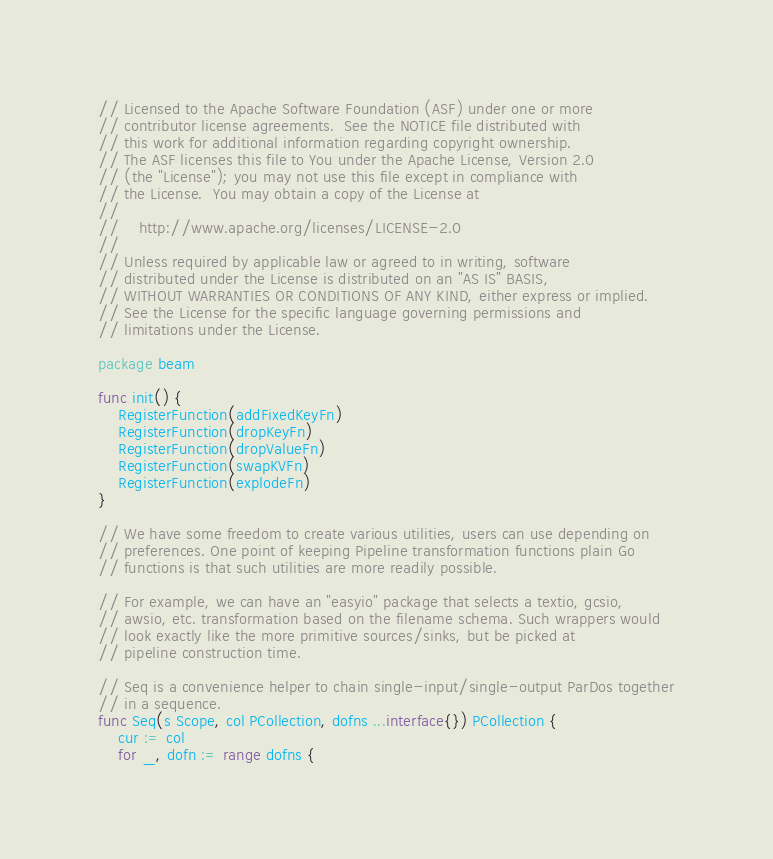Convert code to text. <code><loc_0><loc_0><loc_500><loc_500><_Go_>// Licensed to the Apache Software Foundation (ASF) under one or more
// contributor license agreements.  See the NOTICE file distributed with
// this work for additional information regarding copyright ownership.
// The ASF licenses this file to You under the Apache License, Version 2.0
// (the "License"); you may not use this file except in compliance with
// the License.  You may obtain a copy of the License at
//
//    http://www.apache.org/licenses/LICENSE-2.0
//
// Unless required by applicable law or agreed to in writing, software
// distributed under the License is distributed on an "AS IS" BASIS,
// WITHOUT WARRANTIES OR CONDITIONS OF ANY KIND, either express or implied.
// See the License for the specific language governing permissions and
// limitations under the License.

package beam

func init() {
	RegisterFunction(addFixedKeyFn)
	RegisterFunction(dropKeyFn)
	RegisterFunction(dropValueFn)
	RegisterFunction(swapKVFn)
	RegisterFunction(explodeFn)
}

// We have some freedom to create various utilities, users can use depending on
// preferences. One point of keeping Pipeline transformation functions plain Go
// functions is that such utilities are more readily possible.

// For example, we can have an "easyio" package that selects a textio, gcsio,
// awsio, etc. transformation based on the filename schema. Such wrappers would
// look exactly like the more primitive sources/sinks, but be picked at
// pipeline construction time.

// Seq is a convenience helper to chain single-input/single-output ParDos together
// in a sequence.
func Seq(s Scope, col PCollection, dofns ...interface{}) PCollection {
	cur := col
	for _, dofn := range dofns {</code> 